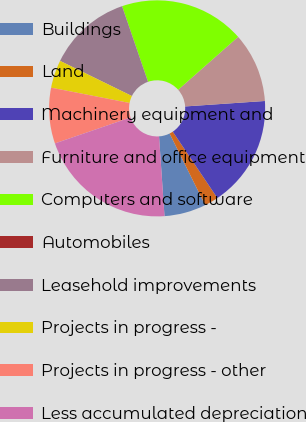<chart> <loc_0><loc_0><loc_500><loc_500><pie_chart><fcel>Buildings<fcel>Land<fcel>Machinery equipment and<fcel>Furniture and office equipment<fcel>Computers and software<fcel>Automobiles<fcel>Leasehold improvements<fcel>Projects in progress -<fcel>Projects in progress - other<fcel>Less accumulated depreciation<nl><fcel>6.25%<fcel>2.08%<fcel>16.67%<fcel>10.42%<fcel>18.75%<fcel>0.0%<fcel>12.5%<fcel>4.17%<fcel>8.33%<fcel>20.83%<nl></chart> 